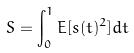Convert formula to latex. <formula><loc_0><loc_0><loc_500><loc_500>S = \int _ { 0 } ^ { 1 } E [ s ( t ) ^ { 2 } ] d t</formula> 